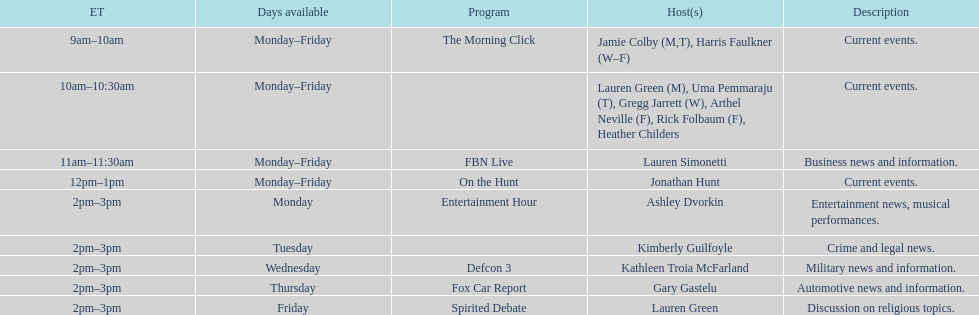How many days is fbn live available each week? 5. 